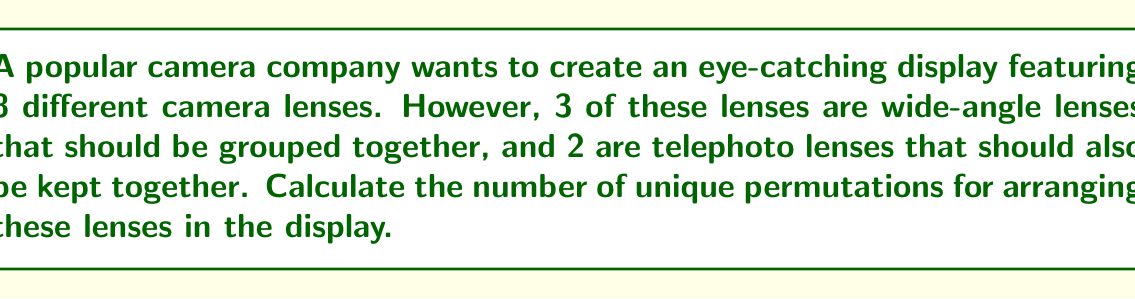Could you help me with this problem? Let's approach this step-by-step:

1) We have 8 total lenses, but we're treating some groups as single units:
   - 3 wide-angle lenses as one unit
   - 2 telephoto lenses as one unit
   - 3 individual lenses

2) So, we're essentially arranging 5 items:
   - The wide-angle group
   - The telephoto group
   - 3 individual lenses

3) The number of permutations for arranging 5 distinct items is:

   $$5! = 5 \times 4 \times 3 \times 2 \times 1 = 120$$

4) However, we're not done. Within the wide-angle group, the 3 lenses can be arranged in $3!$ ways:

   $$3! = 3 \times 2 \times 1 = 6$$

5) Similarly, within the telephoto group, the 2 lenses can be arranged in $2!$ ways:

   $$2! = 2 \times 1 = 2$$

6) By the multiplication principle, the total number of unique permutations is:

   $$5! \times 3! \times 2! = 120 \times 6 \times 2 = 1440$$

This accounts for all possible arrangements of the groups and the individual lenses, as well as all possible arrangements within the grouped lenses.
Answer: $1440$ unique permutations 